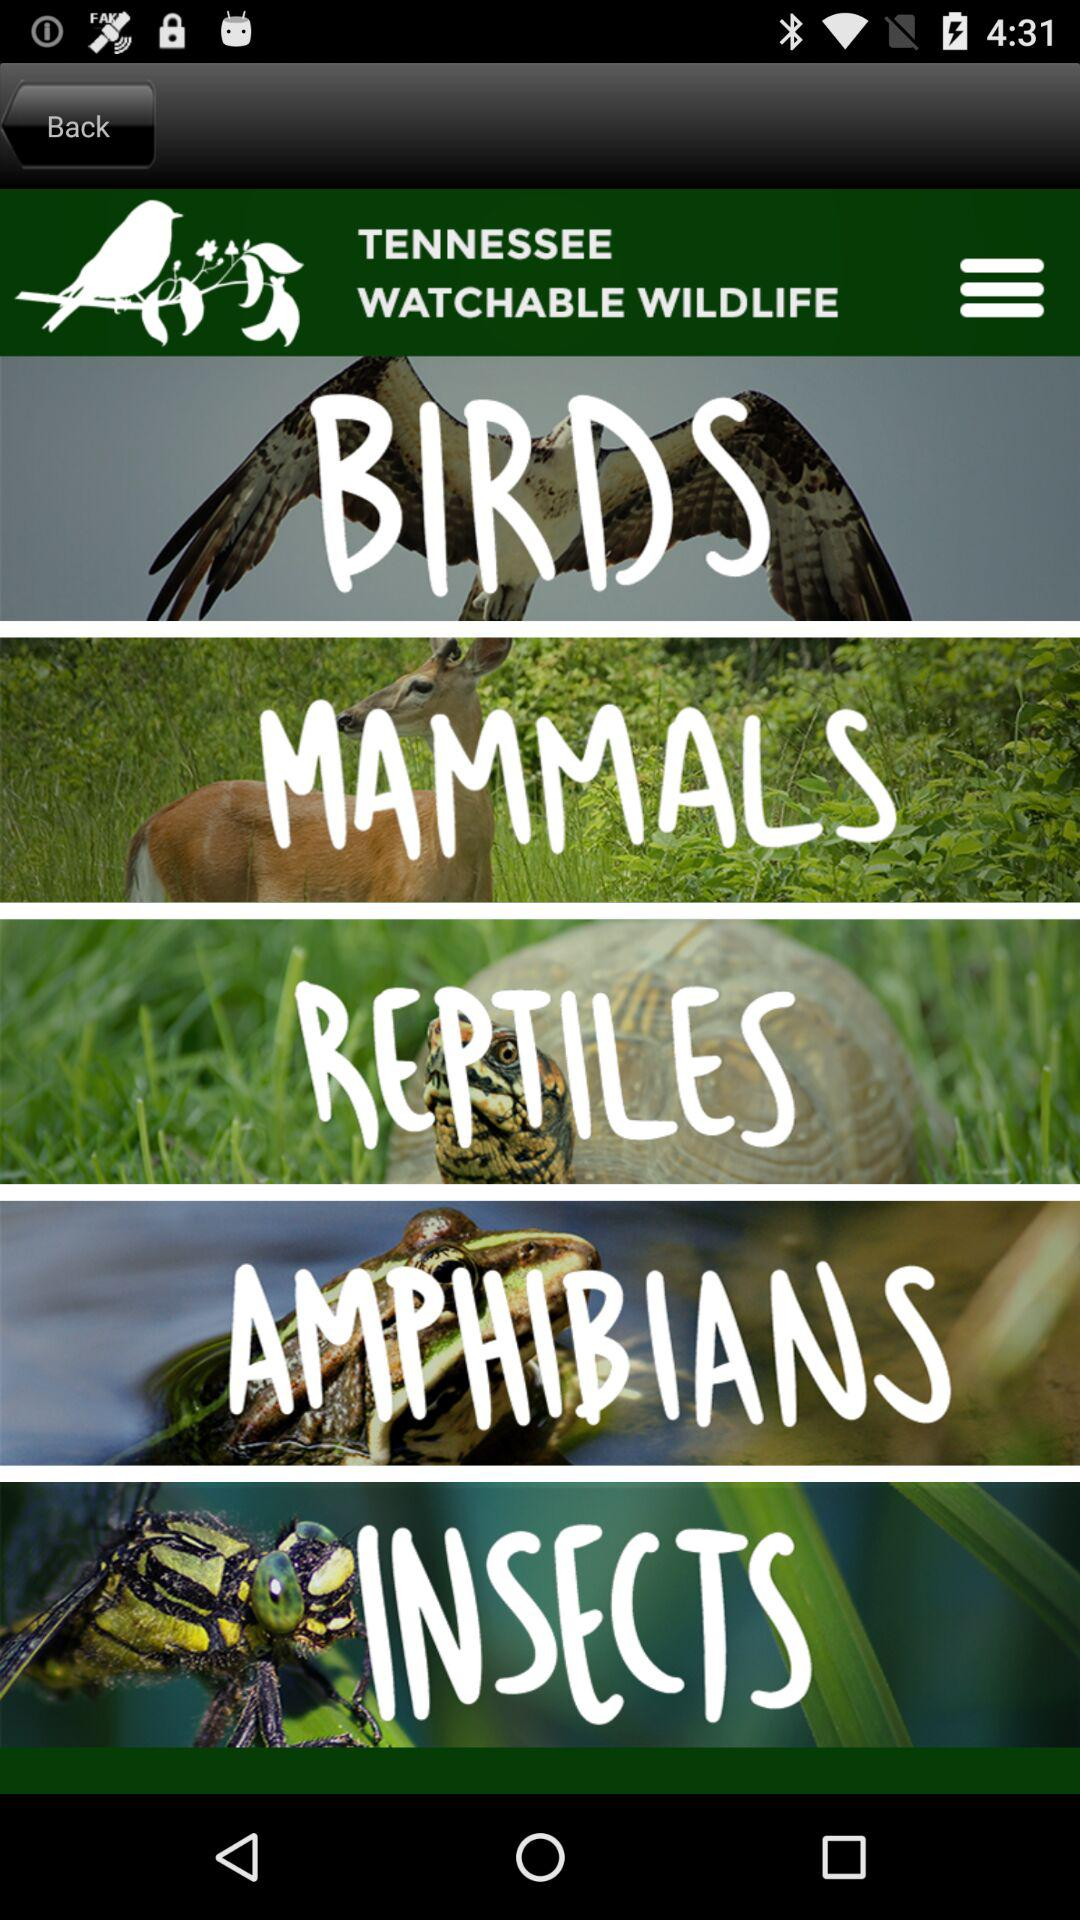What are the categories of wildlife animals available? The categories are "BIRDS", "MAMMALS", "REPTILES", "AMPHIBIANS", and "INSECTS". 